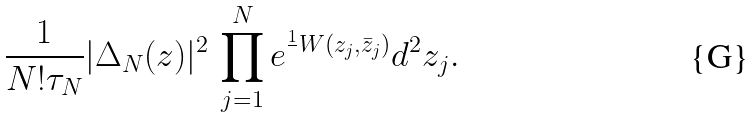<formula> <loc_0><loc_0><loc_500><loc_500>\frac { 1 } { N ! \tau _ { N } } | \Delta _ { N } ( z ) | ^ { 2 } \, \prod _ { j = 1 } ^ { N } e ^ { \frac { 1 } { } W ( z _ { j } , \bar { z } _ { j } ) } d ^ { 2 } z _ { j } .</formula> 